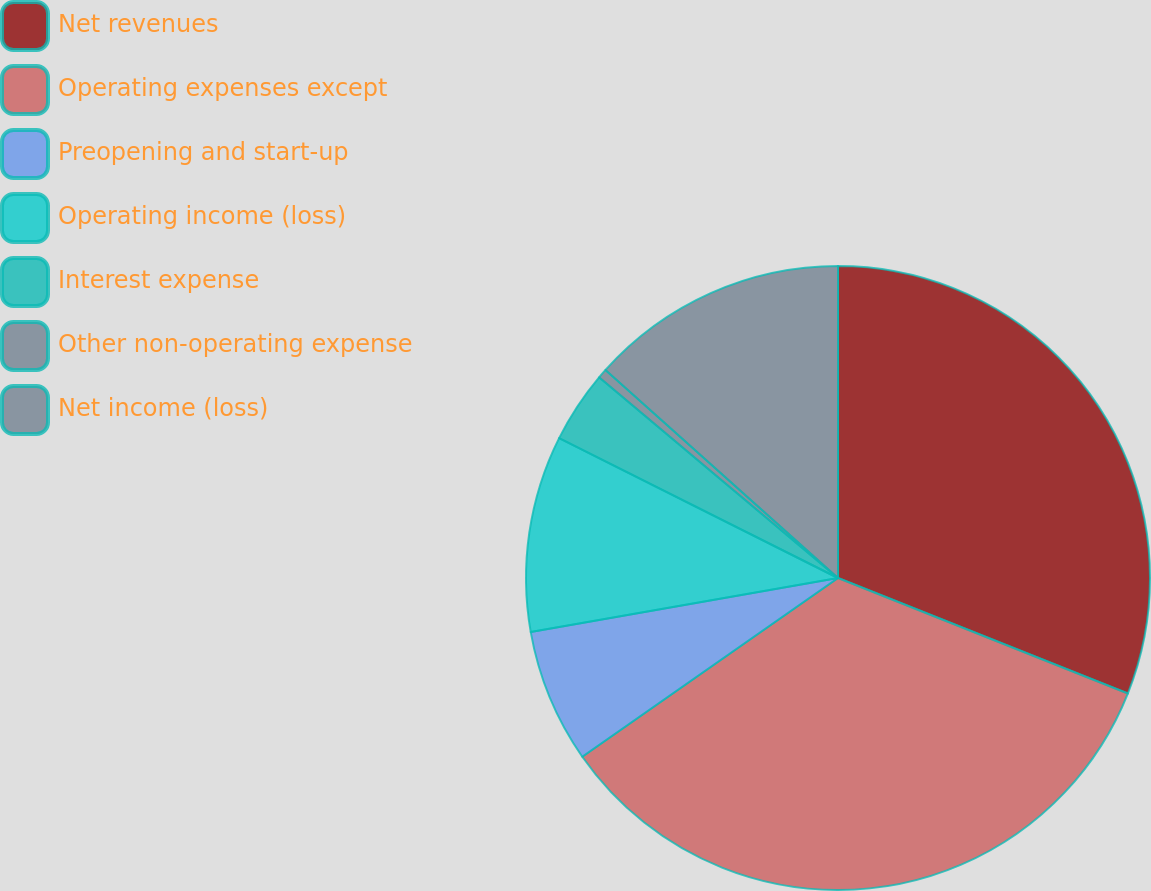<chart> <loc_0><loc_0><loc_500><loc_500><pie_chart><fcel>Net revenues<fcel>Operating expenses except<fcel>Preopening and start-up<fcel>Operating income (loss)<fcel>Interest expense<fcel>Other non-operating expense<fcel>Net income (loss)<nl><fcel>31.03%<fcel>34.25%<fcel>6.94%<fcel>10.16%<fcel>3.72%<fcel>0.5%<fcel>13.38%<nl></chart> 